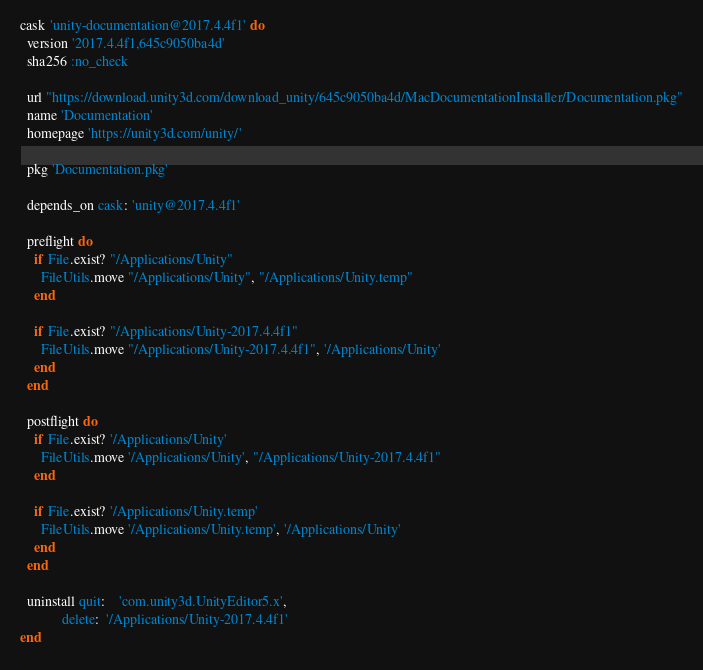Convert code to text. <code><loc_0><loc_0><loc_500><loc_500><_Ruby_>cask 'unity-documentation@2017.4.4f1' do
  version '2017.4.4f1,645c9050ba4d'
  sha256 :no_check

  url "https://download.unity3d.com/download_unity/645c9050ba4d/MacDocumentationInstaller/Documentation.pkg"
  name 'Documentation'
  homepage 'https://unity3d.com/unity/'

  pkg 'Documentation.pkg'

  depends_on cask: 'unity@2017.4.4f1'

  preflight do
    if File.exist? "/Applications/Unity"
      FileUtils.move "/Applications/Unity", "/Applications/Unity.temp"
    end

    if File.exist? "/Applications/Unity-2017.4.4f1"
      FileUtils.move "/Applications/Unity-2017.4.4f1", '/Applications/Unity'
    end
  end

  postflight do
    if File.exist? '/Applications/Unity'
      FileUtils.move '/Applications/Unity', "/Applications/Unity-2017.4.4f1"
    end

    if File.exist? '/Applications/Unity.temp'
      FileUtils.move '/Applications/Unity.temp', '/Applications/Unity'
    end
  end

  uninstall quit:    'com.unity3d.UnityEditor5.x',
            delete:  '/Applications/Unity-2017.4.4f1'
end
</code> 